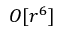Convert formula to latex. <formula><loc_0><loc_0><loc_500><loc_500>O [ r ^ { 6 } ]</formula> 